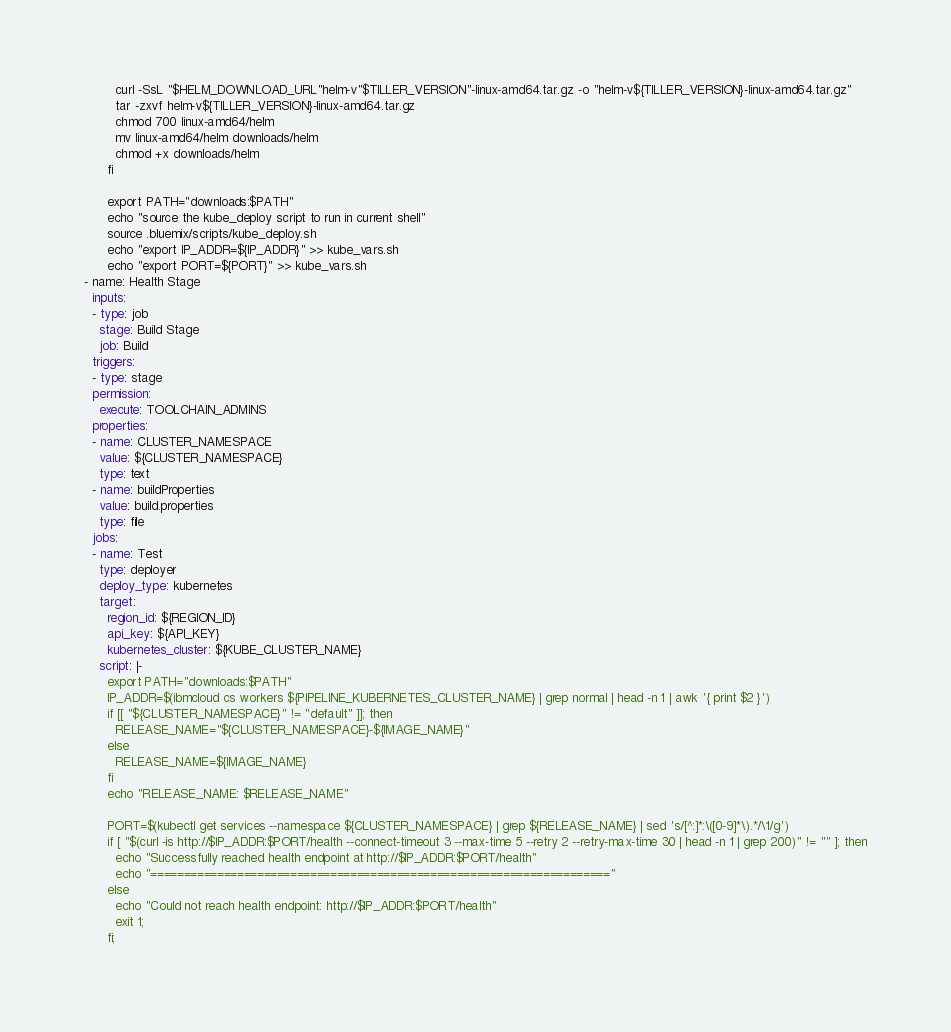Convert code to text. <code><loc_0><loc_0><loc_500><loc_500><_YAML_>        curl -SsL "$HELM_DOWNLOAD_URL"helm-v"$TILLER_VERSION"-linux-amd64.tar.gz -o "helm-v${TILLER_VERSION}-linux-amd64.tar.gz"
        tar -zxvf helm-v${TILLER_VERSION}-linux-amd64.tar.gz
        chmod 700 linux-amd64/helm
        mv linux-amd64/helm downloads/helm
        chmod +x downloads/helm
      fi

      export PATH="downloads:$PATH"
      echo "source the kube_deploy script to run in current shell"
      source .bluemix/scripts/kube_deploy.sh
      echo "export IP_ADDR=${IP_ADDR}" >> kube_vars.sh
      echo "export PORT=${PORT}" >> kube_vars.sh
- name: Health Stage
  inputs:
  - type: job
    stage: Build Stage
    job: Build
  triggers:
  - type: stage
  permission:
    execute: TOOLCHAIN_ADMINS
  properties:
  - name: CLUSTER_NAMESPACE
    value: ${CLUSTER_NAMESPACE}
    type: text
  - name: buildProperties
    value: build.properties
    type: file
  jobs:
  - name: Test
    type: deployer
    deploy_type: kubernetes
    target:
      region_id: ${REGION_ID}
      api_key: ${API_KEY}
      kubernetes_cluster: ${KUBE_CLUSTER_NAME}
    script: |-
      export PATH="downloads:$PATH"
      IP_ADDR=$(ibmcloud cs workers ${PIPELINE_KUBERNETES_CLUSTER_NAME} | grep normal | head -n 1 | awk '{ print $2 }')
      if [[ "${CLUSTER_NAMESPACE}" != "default" ]]; then
        RELEASE_NAME="${CLUSTER_NAMESPACE}-${IMAGE_NAME}"
      else
        RELEASE_NAME=${IMAGE_NAME}
      fi
      echo "RELEASE_NAME: $RELEASE_NAME"

      PORT=$(kubectl get services --namespace ${CLUSTER_NAMESPACE} | grep ${RELEASE_NAME} | sed 's/[^:]*:\([0-9]*\).*/\1/g')
      if [ "$(curl -is http://$IP_ADDR:$PORT/health --connect-timeout 3 --max-time 5 --retry 2 --retry-max-time 30 | head -n 1 | grep 200)" != "" ]; then
        echo "Successfully reached health endpoint at http://$IP_ADDR:$PORT/health"
        echo "====================================================================="
      else
        echo "Could not reach health endpoint: http://$IP_ADDR:$PORT/health"
        exit 1;
      fi;

</code> 